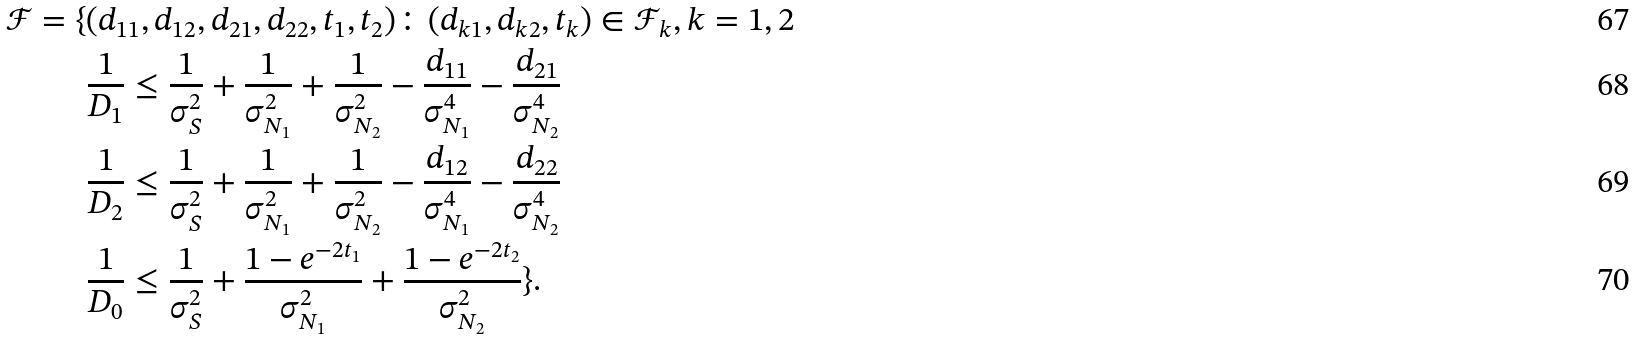Convert formula to latex. <formula><loc_0><loc_0><loc_500><loc_500>\mathcal { F } = \{ & ( d _ { 1 1 } , d _ { 1 2 } , d _ { 2 1 } , d _ { 2 2 } , t _ { 1 } , t _ { 2 } ) \colon ( d _ { k 1 } , d _ { k 2 } , t _ { k } ) \in \mathcal { F } _ { k } , k = 1 , 2 \\ & \frac { 1 } { D _ { 1 } } \leq \frac { 1 } { \sigma _ { S } ^ { 2 } } + \frac { 1 } { \sigma _ { N _ { 1 } } ^ { 2 } } + \frac { 1 } { \sigma _ { N _ { 2 } } ^ { 2 } } - \frac { d _ { 1 1 } } { \sigma _ { N _ { 1 } } ^ { 4 } } - \frac { d _ { 2 1 } } { \sigma _ { N _ { 2 } } ^ { 4 } } \\ & \frac { 1 } { D _ { 2 } } \leq \frac { 1 } { \sigma _ { S } ^ { 2 } } + \frac { 1 } { \sigma _ { N _ { 1 } } ^ { 2 } } + \frac { 1 } { \sigma _ { N _ { 2 } } ^ { 2 } } - \frac { d _ { 1 2 } } { \sigma _ { N _ { 1 } } ^ { 4 } } - \frac { d _ { 2 2 } } { \sigma _ { N _ { 2 } } ^ { 4 } } \\ & \frac { 1 } { D _ { 0 } } \leq \frac { 1 } { \sigma _ { S } ^ { 2 } } + \frac { 1 - e ^ { - 2 t _ { 1 } } } { \sigma _ { N _ { 1 } } ^ { 2 } } + \frac { 1 - e ^ { - 2 t _ { 2 } } } { \sigma _ { N _ { 2 } } ^ { 2 } } \} .</formula> 